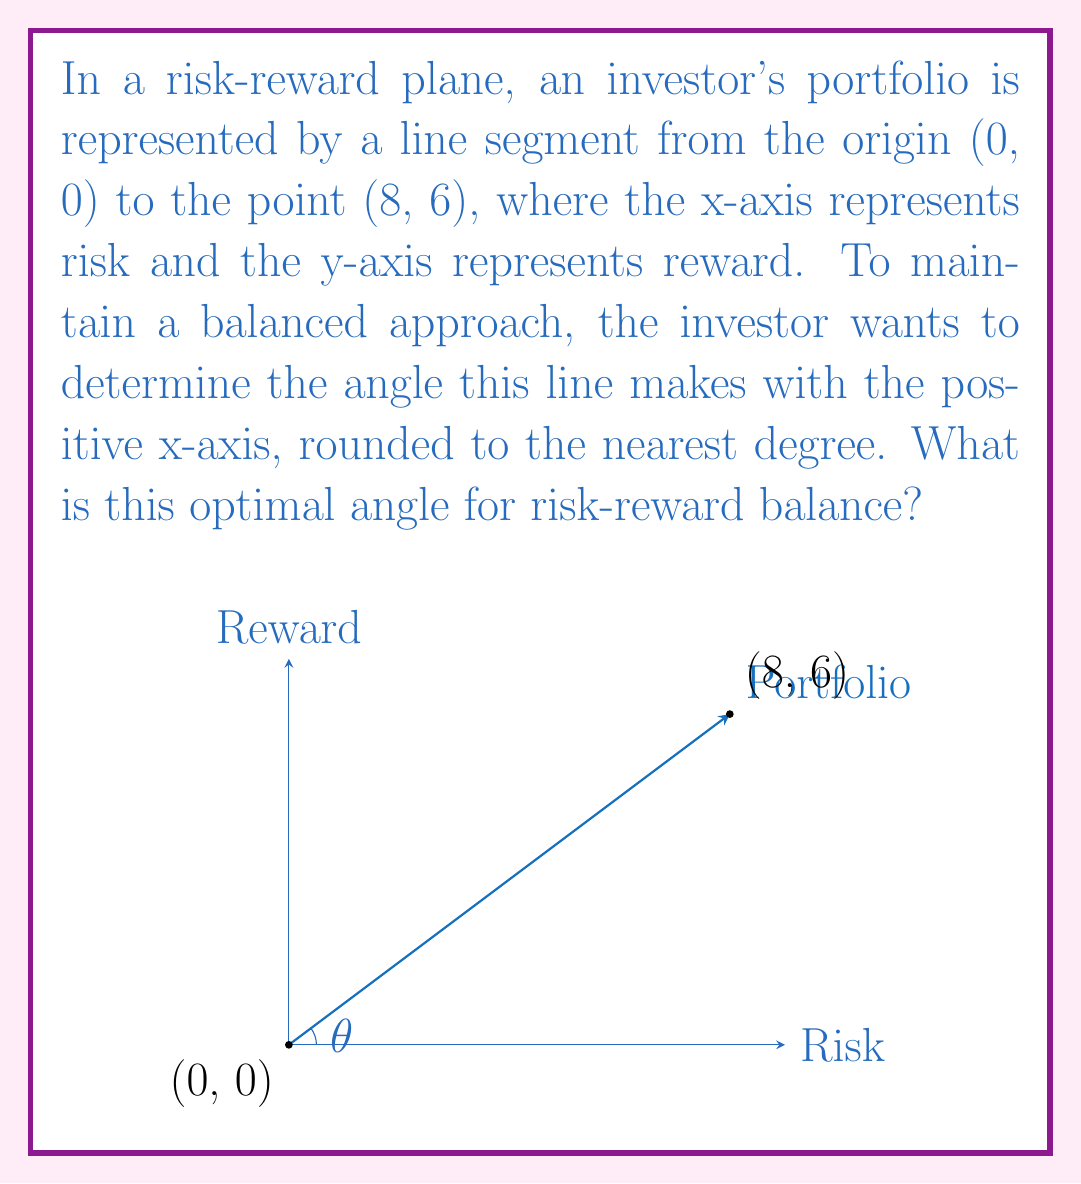Teach me how to tackle this problem. Let's approach this step-by-step:

1) In a right-angled triangle, the tangent of an angle is the ratio of the opposite side to the adjacent side.

2) In our case, the angle $\theta$ is formed between the portfolio line and the x-axis (risk axis).

3) The opposite side is the y-coordinate (reward) = 6
   The adjacent side is the x-coordinate (risk) = 8

4) Therefore, $\tan(\theta) = \frac{\text{opposite}}{\text{adjacent}} = \frac{6}{8} = \frac{3}{4} = 0.75$

5) To find $\theta$, we need to use the inverse tangent (arctan or $\tan^{-1}$) function:

   $\theta = \tan^{-1}(0.75)$

6) Using a calculator or computing software:

   $\theta \approx 36.8699^\circ$

7) Rounding to the nearest degree:

   $\theta \approx 37^\circ$

This angle represents the optimal balance between risk and reward for this portfolio, according to the given constraints.
Answer: $37^\circ$ 